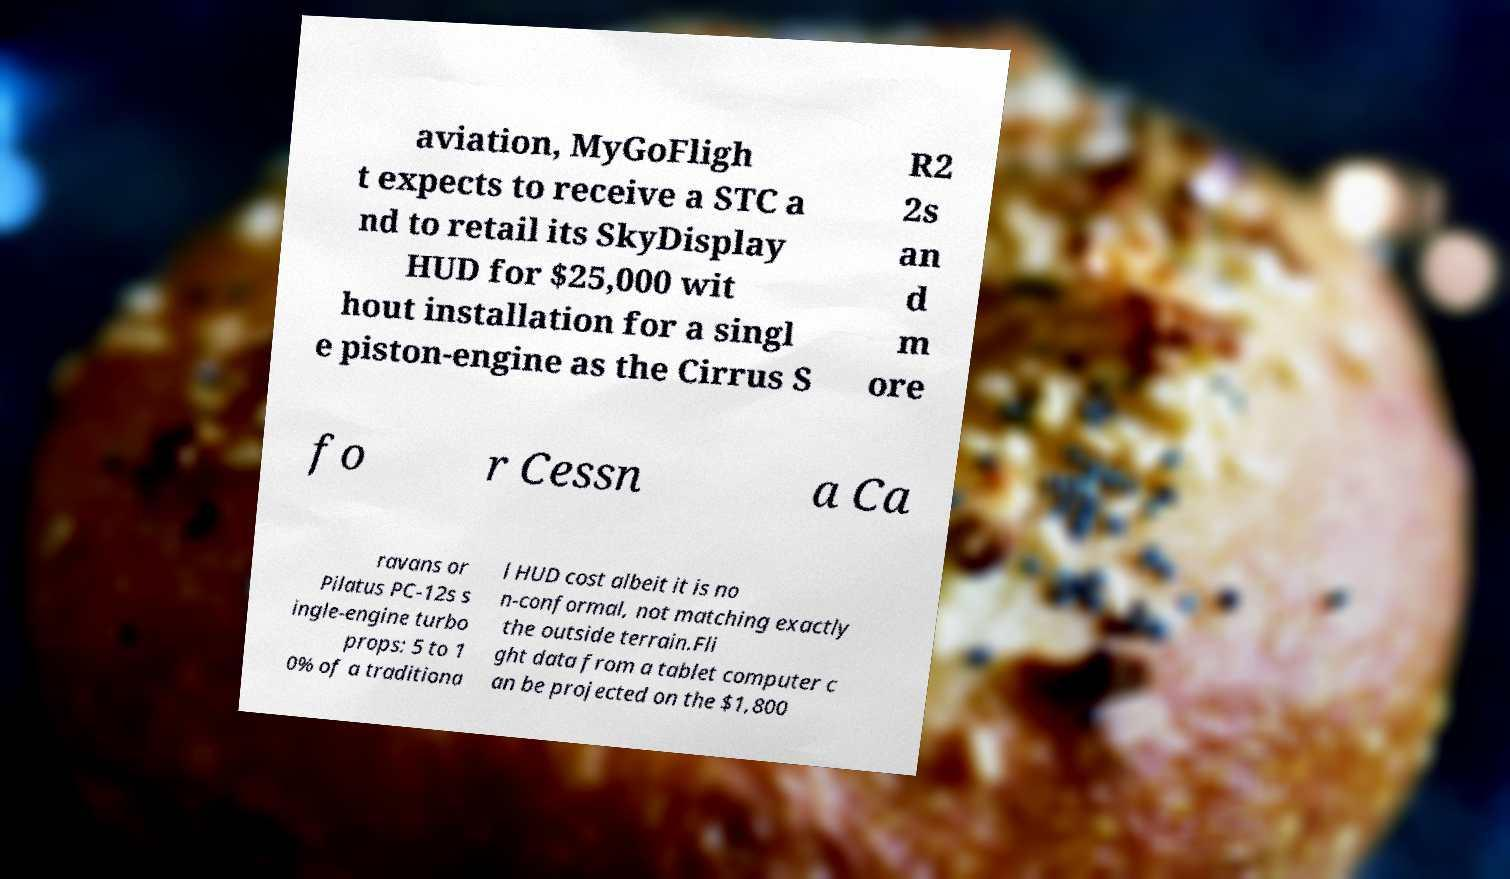Can you accurately transcribe the text from the provided image for me? aviation, MyGoFligh t expects to receive a STC a nd to retail its SkyDisplay HUD for $25,000 wit hout installation for a singl e piston-engine as the Cirrus S R2 2s an d m ore fo r Cessn a Ca ravans or Pilatus PC-12s s ingle-engine turbo props: 5 to 1 0% of a traditiona l HUD cost albeit it is no n-conformal, not matching exactly the outside terrain.Fli ght data from a tablet computer c an be projected on the $1,800 